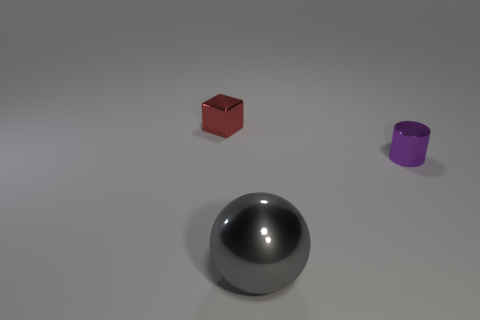How many matte things are either purple things or large objects?
Keep it short and to the point. 0. Do the small metallic thing that is left of the gray sphere and the thing that is in front of the tiny purple metallic cylinder have the same color?
Offer a very short reply. No. Are there any other things that are made of the same material as the purple object?
Provide a short and direct response. Yes. Is the number of small red things in front of the gray shiny thing greater than the number of balls?
Provide a short and direct response. No. Are the small thing behind the purple cylinder and the tiny purple cylinder made of the same material?
Ensure brevity in your answer.  Yes. What is the size of the shiny object left of the object in front of the tiny shiny thing on the right side of the big gray sphere?
Offer a very short reply. Small. The cube that is made of the same material as the tiny purple thing is what size?
Ensure brevity in your answer.  Small. What color is the metallic thing that is both to the left of the purple metal thing and right of the tiny red cube?
Your response must be concise. Gray. Does the tiny shiny thing that is right of the gray metallic thing have the same shape as the small metallic thing that is left of the tiny purple metal thing?
Keep it short and to the point. No. There is a small thing that is on the left side of the tiny cylinder; what is its material?
Provide a short and direct response. Metal. 